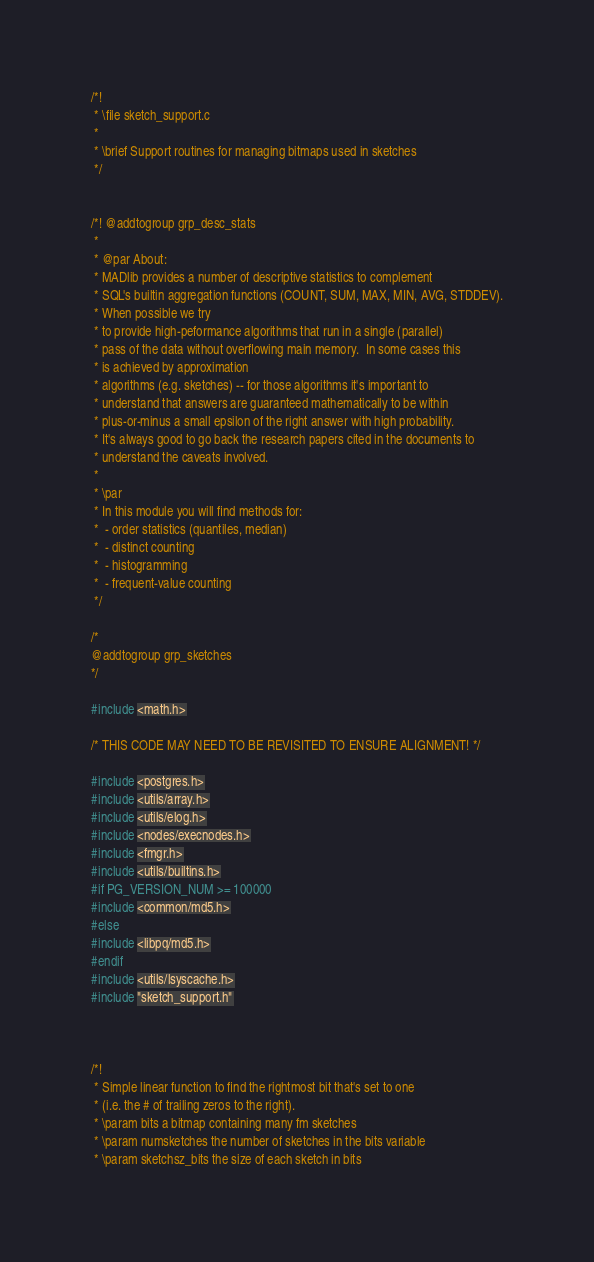<code> <loc_0><loc_0><loc_500><loc_500><_C_>/*!
 * \file sketch_support.c
 *
 * \brief Support routines for managing bitmaps used in sketches
 */


/*! @addtogroup grp_desc_stats
 *
 * @par About:
 * MADlib provides a number of descriptive statistics to complement
 * SQL's builtin aggregation functions (COUNT, SUM, MAX, MIN, AVG, STDDEV).
 * When possible we try
 * to provide high-peformance algorithms that run in a single (parallel)
 * pass of the data without overflowing main memory.  In some cases this
 * is achieved by approximation
 * algorithms (e.g. sketches) -- for those algorithms it's important to
 * understand that answers are guaranteed mathematically to be within
 * plus-or-minus a small epsilon of the right answer with high probability.
 * It's always good to go back the research papers cited in the documents to
 * understand the caveats involved.
 *
 * \par
 * In this module you will find methods for:
 *  - order statistics (quantiles, median)
 *  - distinct counting
 *  - histogramming
 *  - frequent-value counting
 */

/*
@addtogroup grp_sketches
*/

#include <math.h>

/* THIS CODE MAY NEED TO BE REVISITED TO ENSURE ALIGNMENT! */

#include <postgres.h>
#include <utils/array.h>
#include <utils/elog.h>
#include <nodes/execnodes.h>
#include <fmgr.h>
#include <utils/builtins.h>
#if PG_VERSION_NUM >= 100000
#include <common/md5.h>
#else
#include <libpq/md5.h>
#endif
#include <utils/lsyscache.h>
#include "sketch_support.h"



/*!
 * Simple linear function to find the rightmost bit that's set to one
 * (i.e. the # of trailing zeros to the right).
 * \param bits a bitmap containing many fm sketches
 * \param numsketches the number of sketches in the bits variable
 * \param sketchsz_bits the size of each sketch in bits</code> 